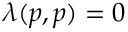<formula> <loc_0><loc_0><loc_500><loc_500>\lambda ( p , p ) = 0</formula> 